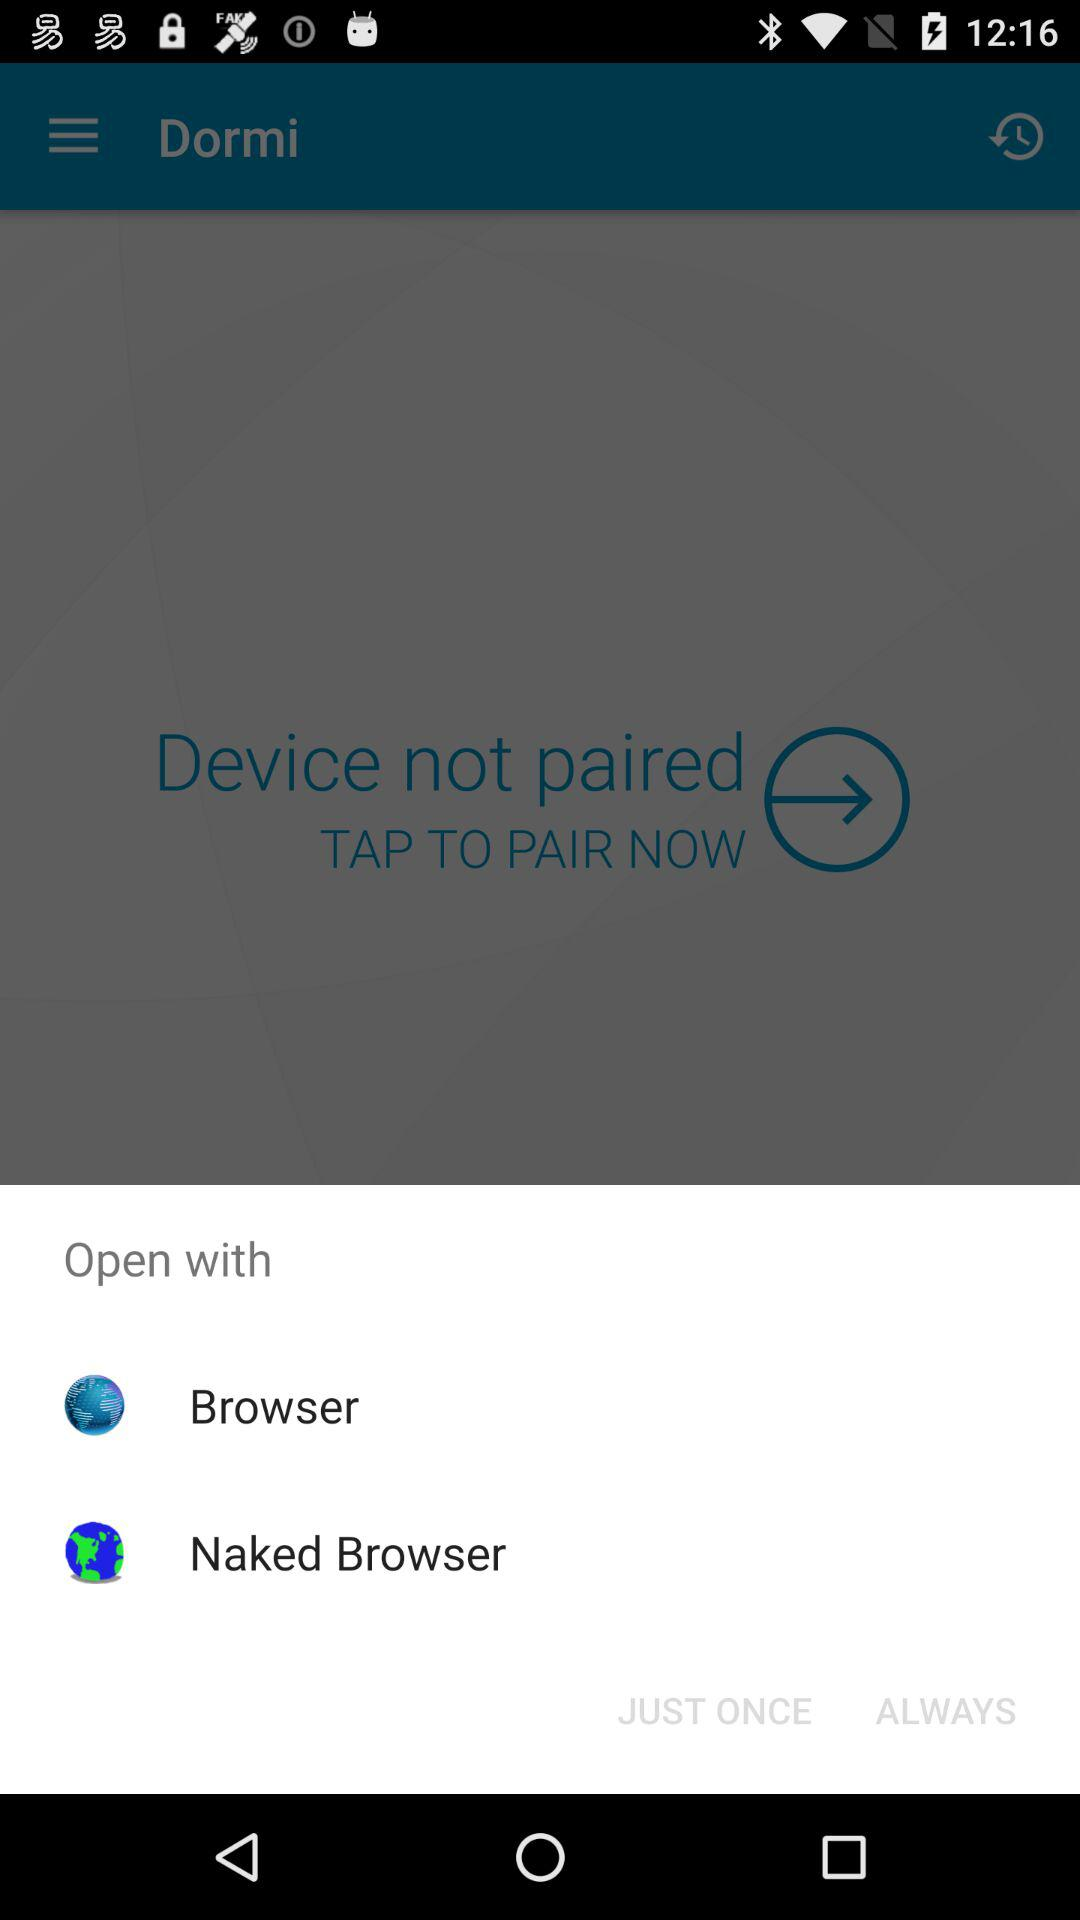What application can we open with? You can open with "Naked Browser". 